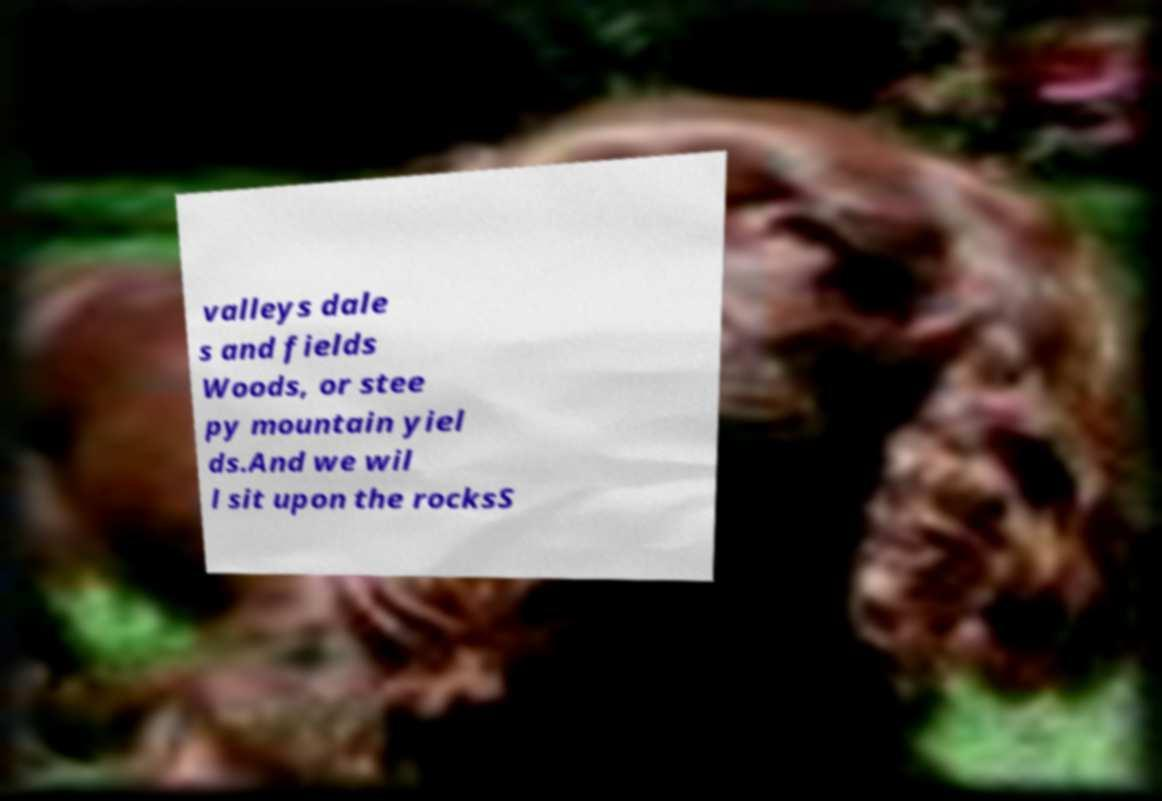Can you read and provide the text displayed in the image?This photo seems to have some interesting text. Can you extract and type it out for me? valleys dale s and fields Woods, or stee py mountain yiel ds.And we wil l sit upon the rocksS 